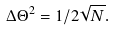Convert formula to latex. <formula><loc_0><loc_0><loc_500><loc_500>\Delta \Theta ^ { 2 } = { 1 } / { 2 \sqrt { N } } .</formula> 